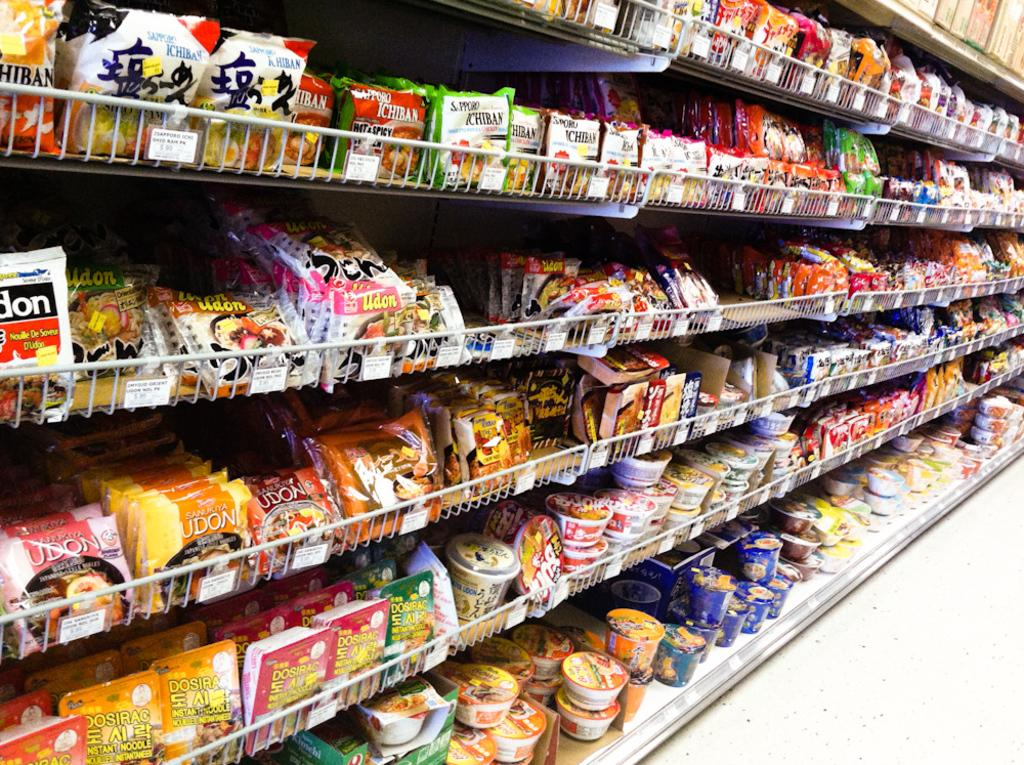<image>
Give a short and clear explanation of the subsequent image. Several packages of Udon noodles are on a store shelf. 